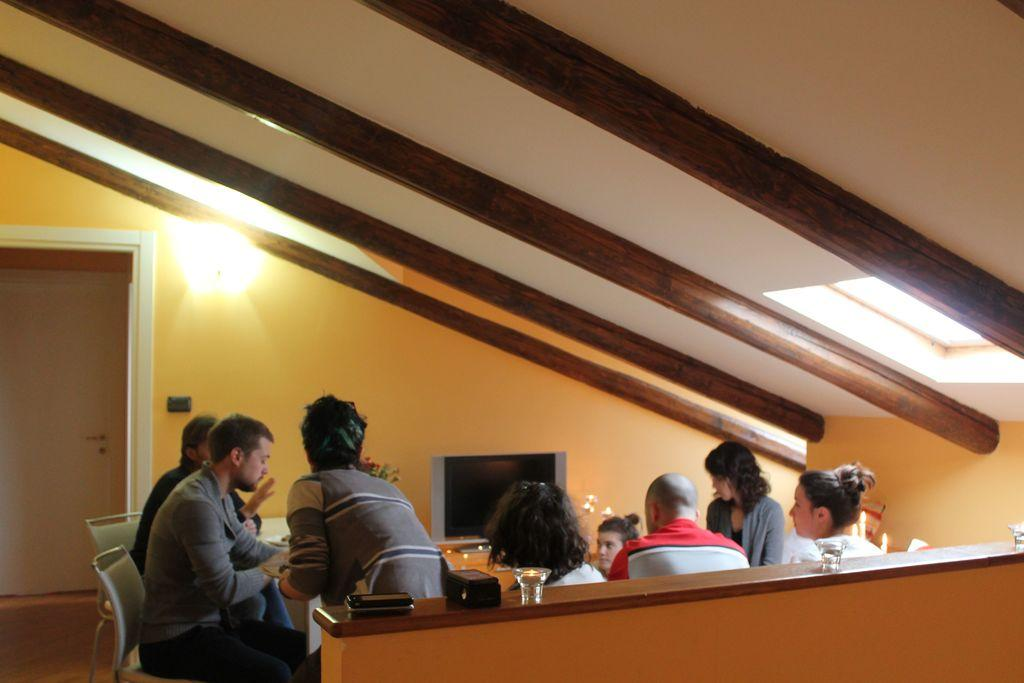How many people are in the image? There is a group of people in the image. What electronic device can be seen in the image? There is a television in the image. What type of furniture is present in the image? There are chairs and a table in the image. What objects might be used for drinking in the image? There are glasses in the image. What type of lighting is present in the image? There are lights in the image. What other objects can be seen in the image? There are some objects in the image. What can be seen in the background of the image? There is a wall and a door in the background of the image. How many friends are sitting on the tray in the image? There is no tray present in the image, and therefore no friends can be sitting on it. How many cats are visible in the image? There are no cats visible in the image. 